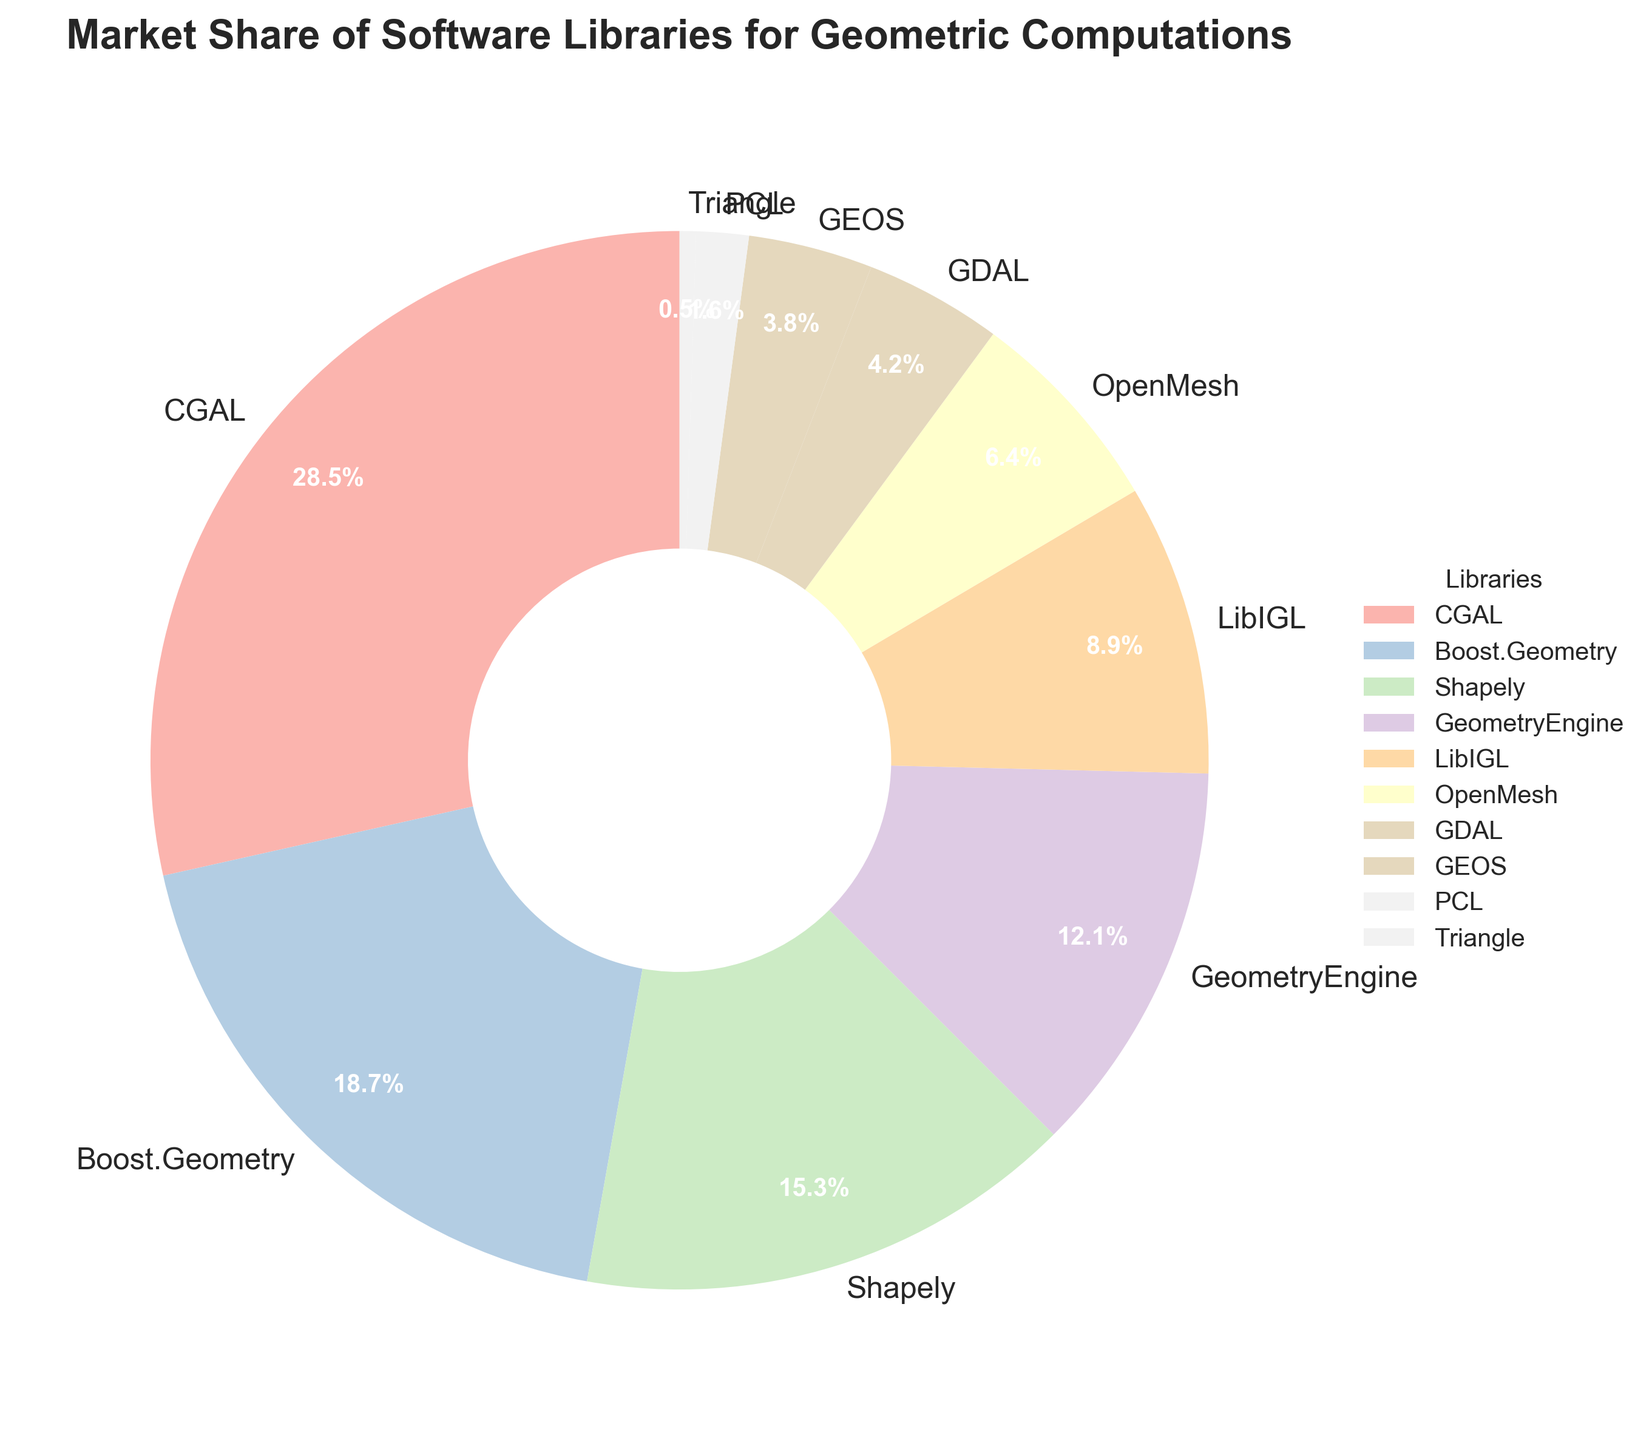How many libraries have a market share greater than 10%? From the chart, identify the slices representing market shares more than 10%. The slices corresponding to CGAL (28.5%), Boost.Geometry (18.7%), Shapely (15.3%), and GeometryEngine (12.1%) are all greater than 10%.
Answer: 4 Which library has the lowest market share, and what is it? Find the smallest slice in the pie chart, which represents Triangle with a market share of 0.5%.
Answer: Triangle, 0.5% What is the combined market share of CGAL and Boost.Geometry? Find the slices for CGAL and Boost.Geometry and add their market shares: 28.5% + 18.7% = 47.2%.
Answer: 47.2% Which libraries combined have a market share close to 50%? Identify the slices and sum to approximate 50%: Shapely (15.3%) + GeometryEngine (12.1%) + LibIGL (8.9%) + OpenMesh (6.4%) + GDAL (4.2%) + GEOS (3.8%) = 50.7%.
Answer: Shapely, GeometryEngine, LibIGL, OpenMesh, GDAL, GEOS Are the market shares of GEOS and PCL together more or less than that of OpenMesh alone? Calculate the combined market share of GEOS and PCL: 3.8% + 1.6% = 5.4%. Compare it to OpenMesh's market share of 6.4%. Since 5.4% is less than 6.4%, the combined share is less.
Answer: Less Which library has a market share almost double that of LibIGL? Determine the market share of LibIGL which is 8.9%, then double it to get 17.8%. The closest value is Boost.Geometry with a market share of 18.7%.
Answer: Boost.Geometry What is the total market share of the three smallest libraries? Identify the smallest three slices: GEOS (3.8%), PCL (1.6%), and Triangle (0.5%). Sum these shares: 3.8% + 1.6% + 0.5% = 5.9%.
Answer: 5.9% Which two libraries have market shares that together total 30.6%? Identify pairs of slices whose market shares sum to 30.6%. CGAL (28.5%) + GEOS (3.8%) = 32.3%, Boost.Geometry (18.7%) + OpenMesh (6.4%) = 25.1%, etc. Shapely (15.3%) + GeometryEngine (12.1%) = 27.4%, Shapely (15.3%) + GDAL (4.2%) = 19.5%, Boost.Geometry (18.7%) + LibIGL (8.9%) = 27.6%, but CGAL and any other library don't add up to 30.6%. Hence, no straightforward combination results in 30.6%.
Answer: None Which library's market share is closer to the average market share? Calculate the average market share as the total market share divided by the number of libraries. The total market share is 100%, and there are 10 libraries, so the average is 100% / 10 = 10%. Compare each library's share to 10%. LibIGL's market share of 8.9% is closest to the average.
Answer: LibIGL 